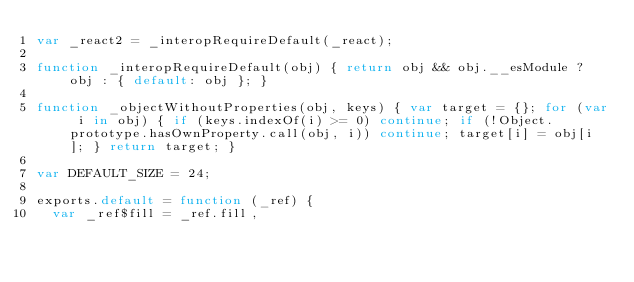Convert code to text. <code><loc_0><loc_0><loc_500><loc_500><_JavaScript_>var _react2 = _interopRequireDefault(_react);

function _interopRequireDefault(obj) { return obj && obj.__esModule ? obj : { default: obj }; }

function _objectWithoutProperties(obj, keys) { var target = {}; for (var i in obj) { if (keys.indexOf(i) >= 0) continue; if (!Object.prototype.hasOwnProperty.call(obj, i)) continue; target[i] = obj[i]; } return target; }

var DEFAULT_SIZE = 24;

exports.default = function (_ref) {
  var _ref$fill = _ref.fill,</code> 